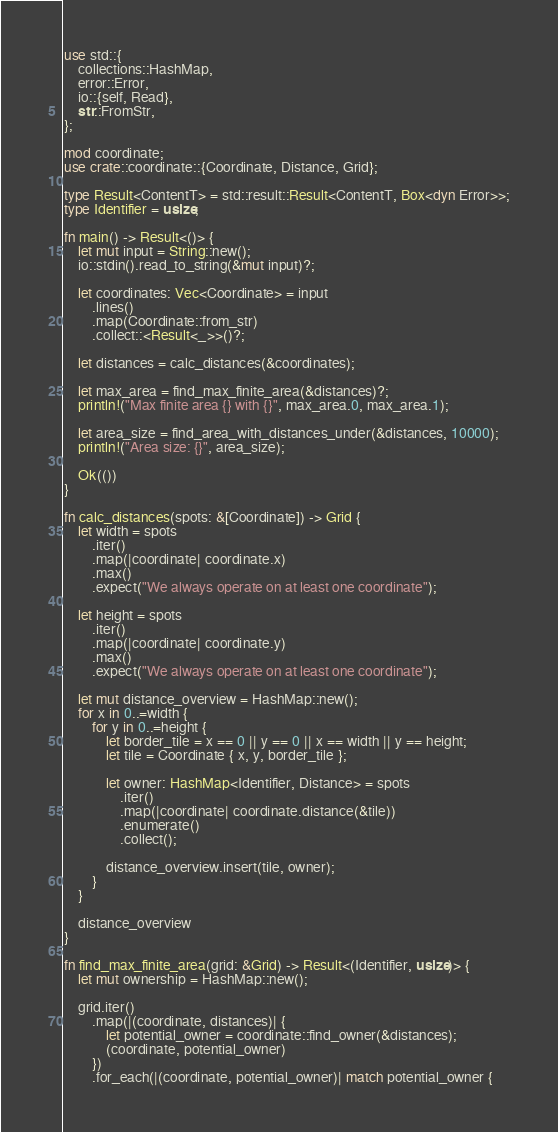Convert code to text. <code><loc_0><loc_0><loc_500><loc_500><_Rust_>use std::{
    collections::HashMap,
    error::Error,
    io::{self, Read},
    str::FromStr,
};

mod coordinate;
use crate::coordinate::{Coordinate, Distance, Grid};

type Result<ContentT> = std::result::Result<ContentT, Box<dyn Error>>;
type Identifier = usize;

fn main() -> Result<()> {
    let mut input = String::new();
    io::stdin().read_to_string(&mut input)?;

    let coordinates: Vec<Coordinate> = input
        .lines()
        .map(Coordinate::from_str)
        .collect::<Result<_>>()?;

    let distances = calc_distances(&coordinates);

    let max_area = find_max_finite_area(&distances)?;
    println!("Max finite area {} with {}", max_area.0, max_area.1);

    let area_size = find_area_with_distances_under(&distances, 10000);
    println!("Area size: {}", area_size);

    Ok(())
}

fn calc_distances(spots: &[Coordinate]) -> Grid {
    let width = spots
        .iter()
        .map(|coordinate| coordinate.x)
        .max()
        .expect("We always operate on at least one coordinate");

    let height = spots
        .iter()
        .map(|coordinate| coordinate.y)
        .max()
        .expect("We always operate on at least one coordinate");

    let mut distance_overview = HashMap::new();
    for x in 0..=width {
        for y in 0..=height {
            let border_tile = x == 0 || y == 0 || x == width || y == height;
            let tile = Coordinate { x, y, border_tile };

            let owner: HashMap<Identifier, Distance> = spots
                .iter()
                .map(|coordinate| coordinate.distance(&tile))
                .enumerate()
                .collect();

            distance_overview.insert(tile, owner);
        }
    }

    distance_overview
}

fn find_max_finite_area(grid: &Grid) -> Result<(Identifier, usize)> {
    let mut ownership = HashMap::new();

    grid.iter()
        .map(|(coordinate, distances)| {
            let potential_owner = coordinate::find_owner(&distances);
            (coordinate, potential_owner)
        })
        .for_each(|(coordinate, potential_owner)| match potential_owner {</code> 